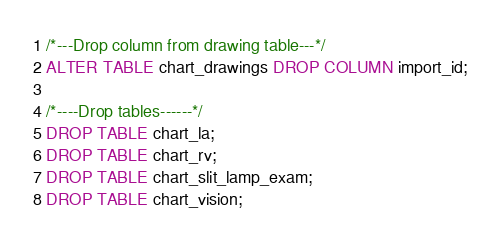<code> <loc_0><loc_0><loc_500><loc_500><_SQL_>
/*---Drop column from drawing table---*/
ALTER TABLE chart_drawings DROP COLUMN import_id;

/*----Drop tables------*/
DROP TABLE chart_la;
DROP TABLE chart_rv;
DROP TABLE chart_slit_lamp_exam;
DROP TABLE chart_vision;
</code> 